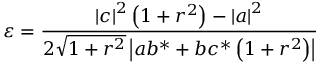Convert formula to latex. <formula><loc_0><loc_0><loc_500><loc_500>\varepsilon = \frac { \left | c \right | ^ { 2 } \left ( 1 + r ^ { 2 } \right ) - \left | a \right | ^ { 2 } } { 2 \sqrt { 1 + r ^ { 2 } } \left | a b ^ { \ast } + b c ^ { \ast } \left ( 1 + r ^ { 2 } \right ) \right | }</formula> 